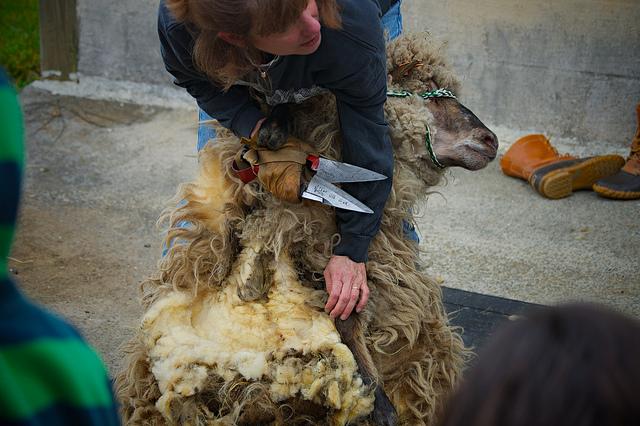Is anyone wearing the boots that are against the wall?
Give a very brief answer. No. What are they doing to the animal in the photo?
Be succinct. Shearing. Does the animal look like this is painful?
Concise answer only. No. 